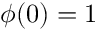<formula> <loc_0><loc_0><loc_500><loc_500>\phi ( 0 ) = 1</formula> 